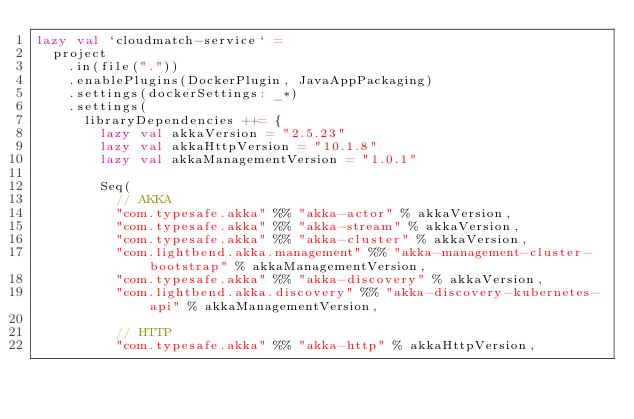Convert code to text. <code><loc_0><loc_0><loc_500><loc_500><_Scala_>lazy val `cloudmatch-service` =
  project
    .in(file("."))
    .enablePlugins(DockerPlugin, JavaAppPackaging)
    .settings(dockerSettings: _*)
    .settings(
      libraryDependencies ++= {
        lazy val akkaVersion = "2.5.23"
        lazy val akkaHttpVersion = "10.1.8"
        lazy val akkaManagementVersion = "1.0.1"

        Seq(
          // AKKA
          "com.typesafe.akka" %% "akka-actor" % akkaVersion,
          "com.typesafe.akka" %% "akka-stream" % akkaVersion,
          "com.typesafe.akka" %% "akka-cluster" % akkaVersion,
          "com.lightbend.akka.management" %% "akka-management-cluster-bootstrap" % akkaManagementVersion,
          "com.typesafe.akka" %% "akka-discovery" % akkaVersion,
          "com.lightbend.akka.discovery" %% "akka-discovery-kubernetes-api" % akkaManagementVersion,

          // HTTP
          "com.typesafe.akka" %% "akka-http" % akkaHttpVersion,</code> 